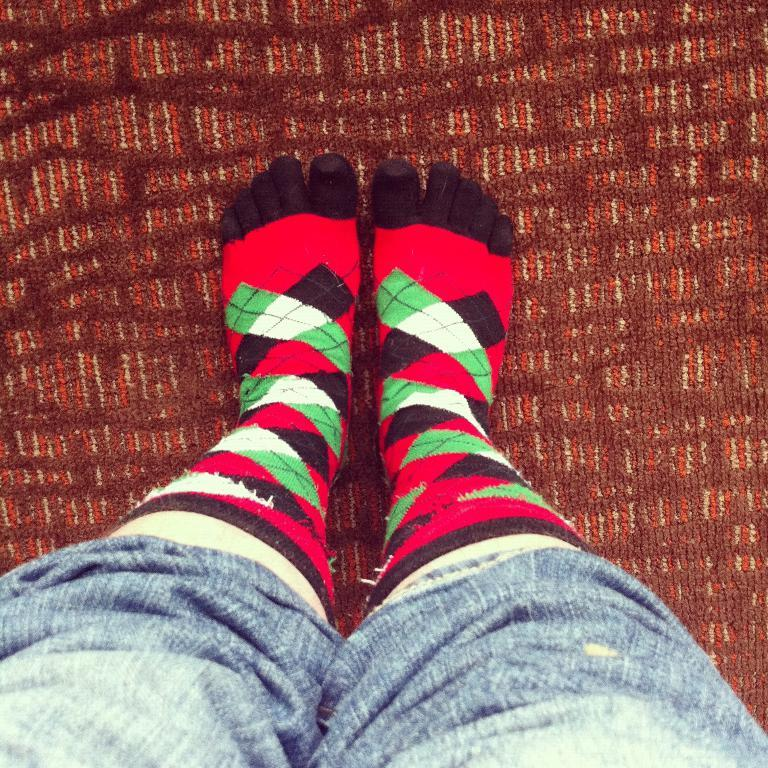What is the main subject of the image? There is a person standing in the image. Where is the person standing? The person is standing on the floor. How is the person positioned in the image? The person is in the middle of the image. What type of toothbrush is the person using in the image? There is no toothbrush present in the image. Can you tell me what news the person is reading in the image? There is no news or reading material visible in the image. 